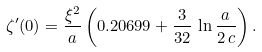Convert formula to latex. <formula><loc_0><loc_0><loc_500><loc_500>\zeta ^ { \prime } ( 0 ) = \frac { \xi ^ { 2 } } { a } \left ( 0 . 2 0 6 9 9 + \frac { 3 } { 3 2 } \, \ln \frac { a } { 2 \, c } \right ) .</formula> 